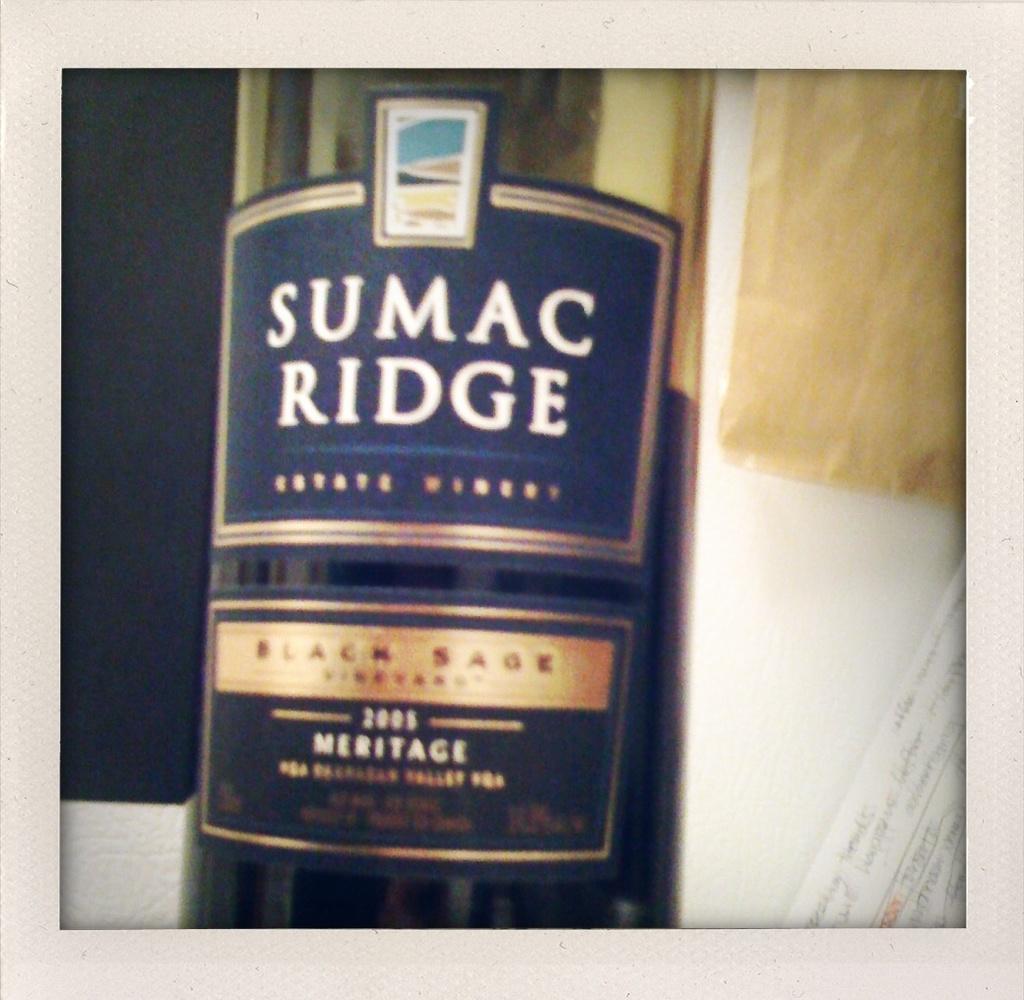Describe this image in one or two sentences. This is a wine bottle. 